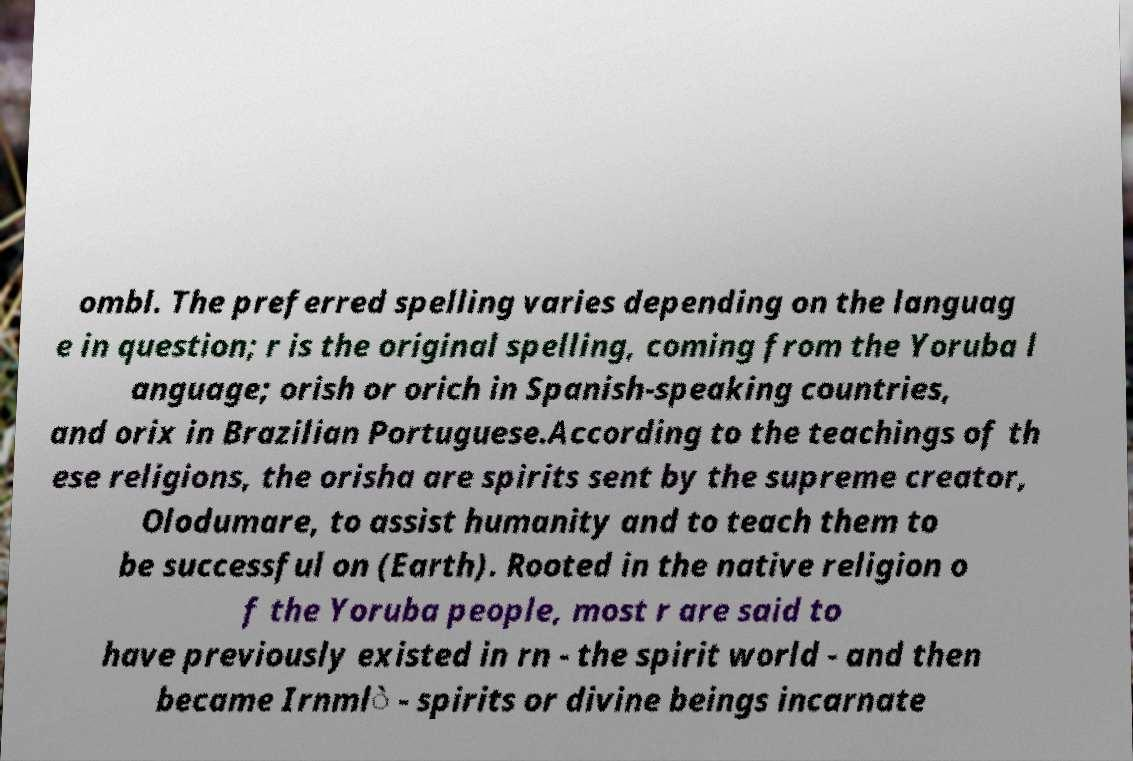For documentation purposes, I need the text within this image transcribed. Could you provide that? ombl. The preferred spelling varies depending on the languag e in question; r is the original spelling, coming from the Yoruba l anguage; orish or orich in Spanish-speaking countries, and orix in Brazilian Portuguese.According to the teachings of th ese religions, the orisha are spirits sent by the supreme creator, Olodumare, to assist humanity and to teach them to be successful on (Earth). Rooted in the native religion o f the Yoruba people, most r are said to have previously existed in rn - the spirit world - and then became Irnml̀ - spirits or divine beings incarnate 